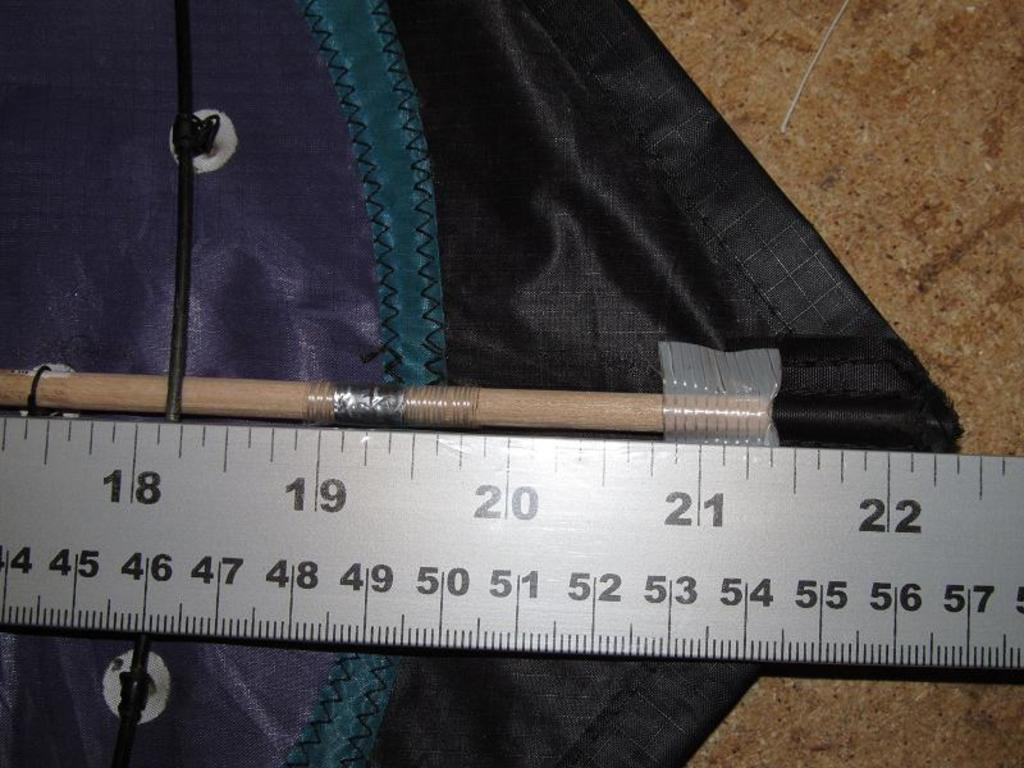<image>
Share a concise interpretation of the image provided. A rod inserted into a pocket of polyester blend fabric with a ruler measuring 22 and 3 eigths inches. 